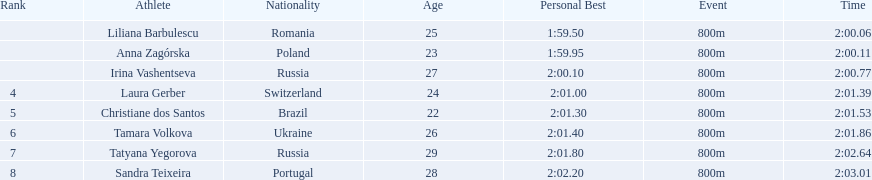Which south american country placed after irina vashentseva? Brazil. 